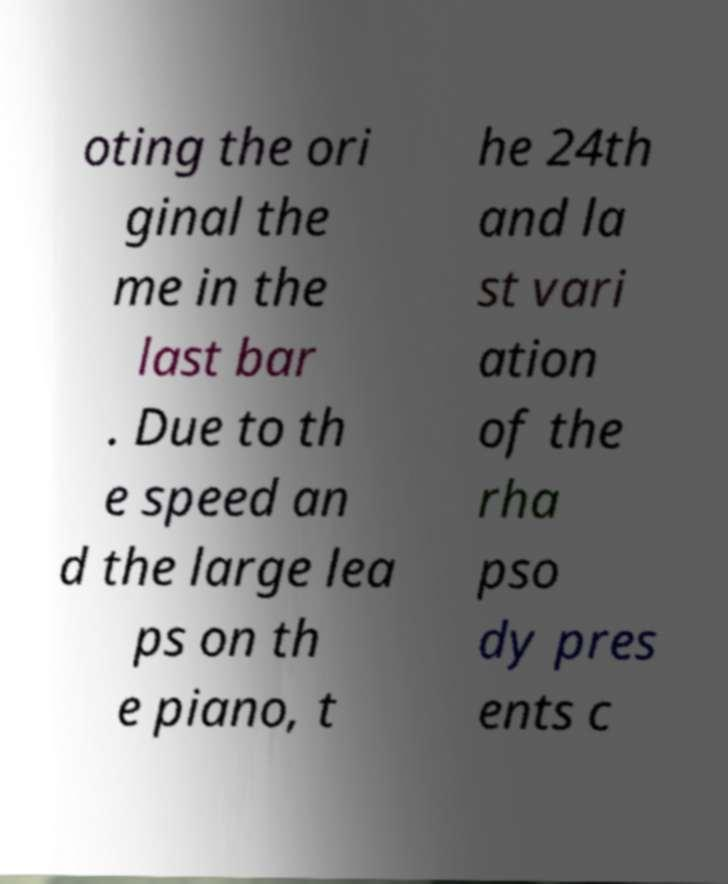Can you accurately transcribe the text from the provided image for me? oting the ori ginal the me in the last bar . Due to th e speed an d the large lea ps on th e piano, t he 24th and la st vari ation of the rha pso dy pres ents c 